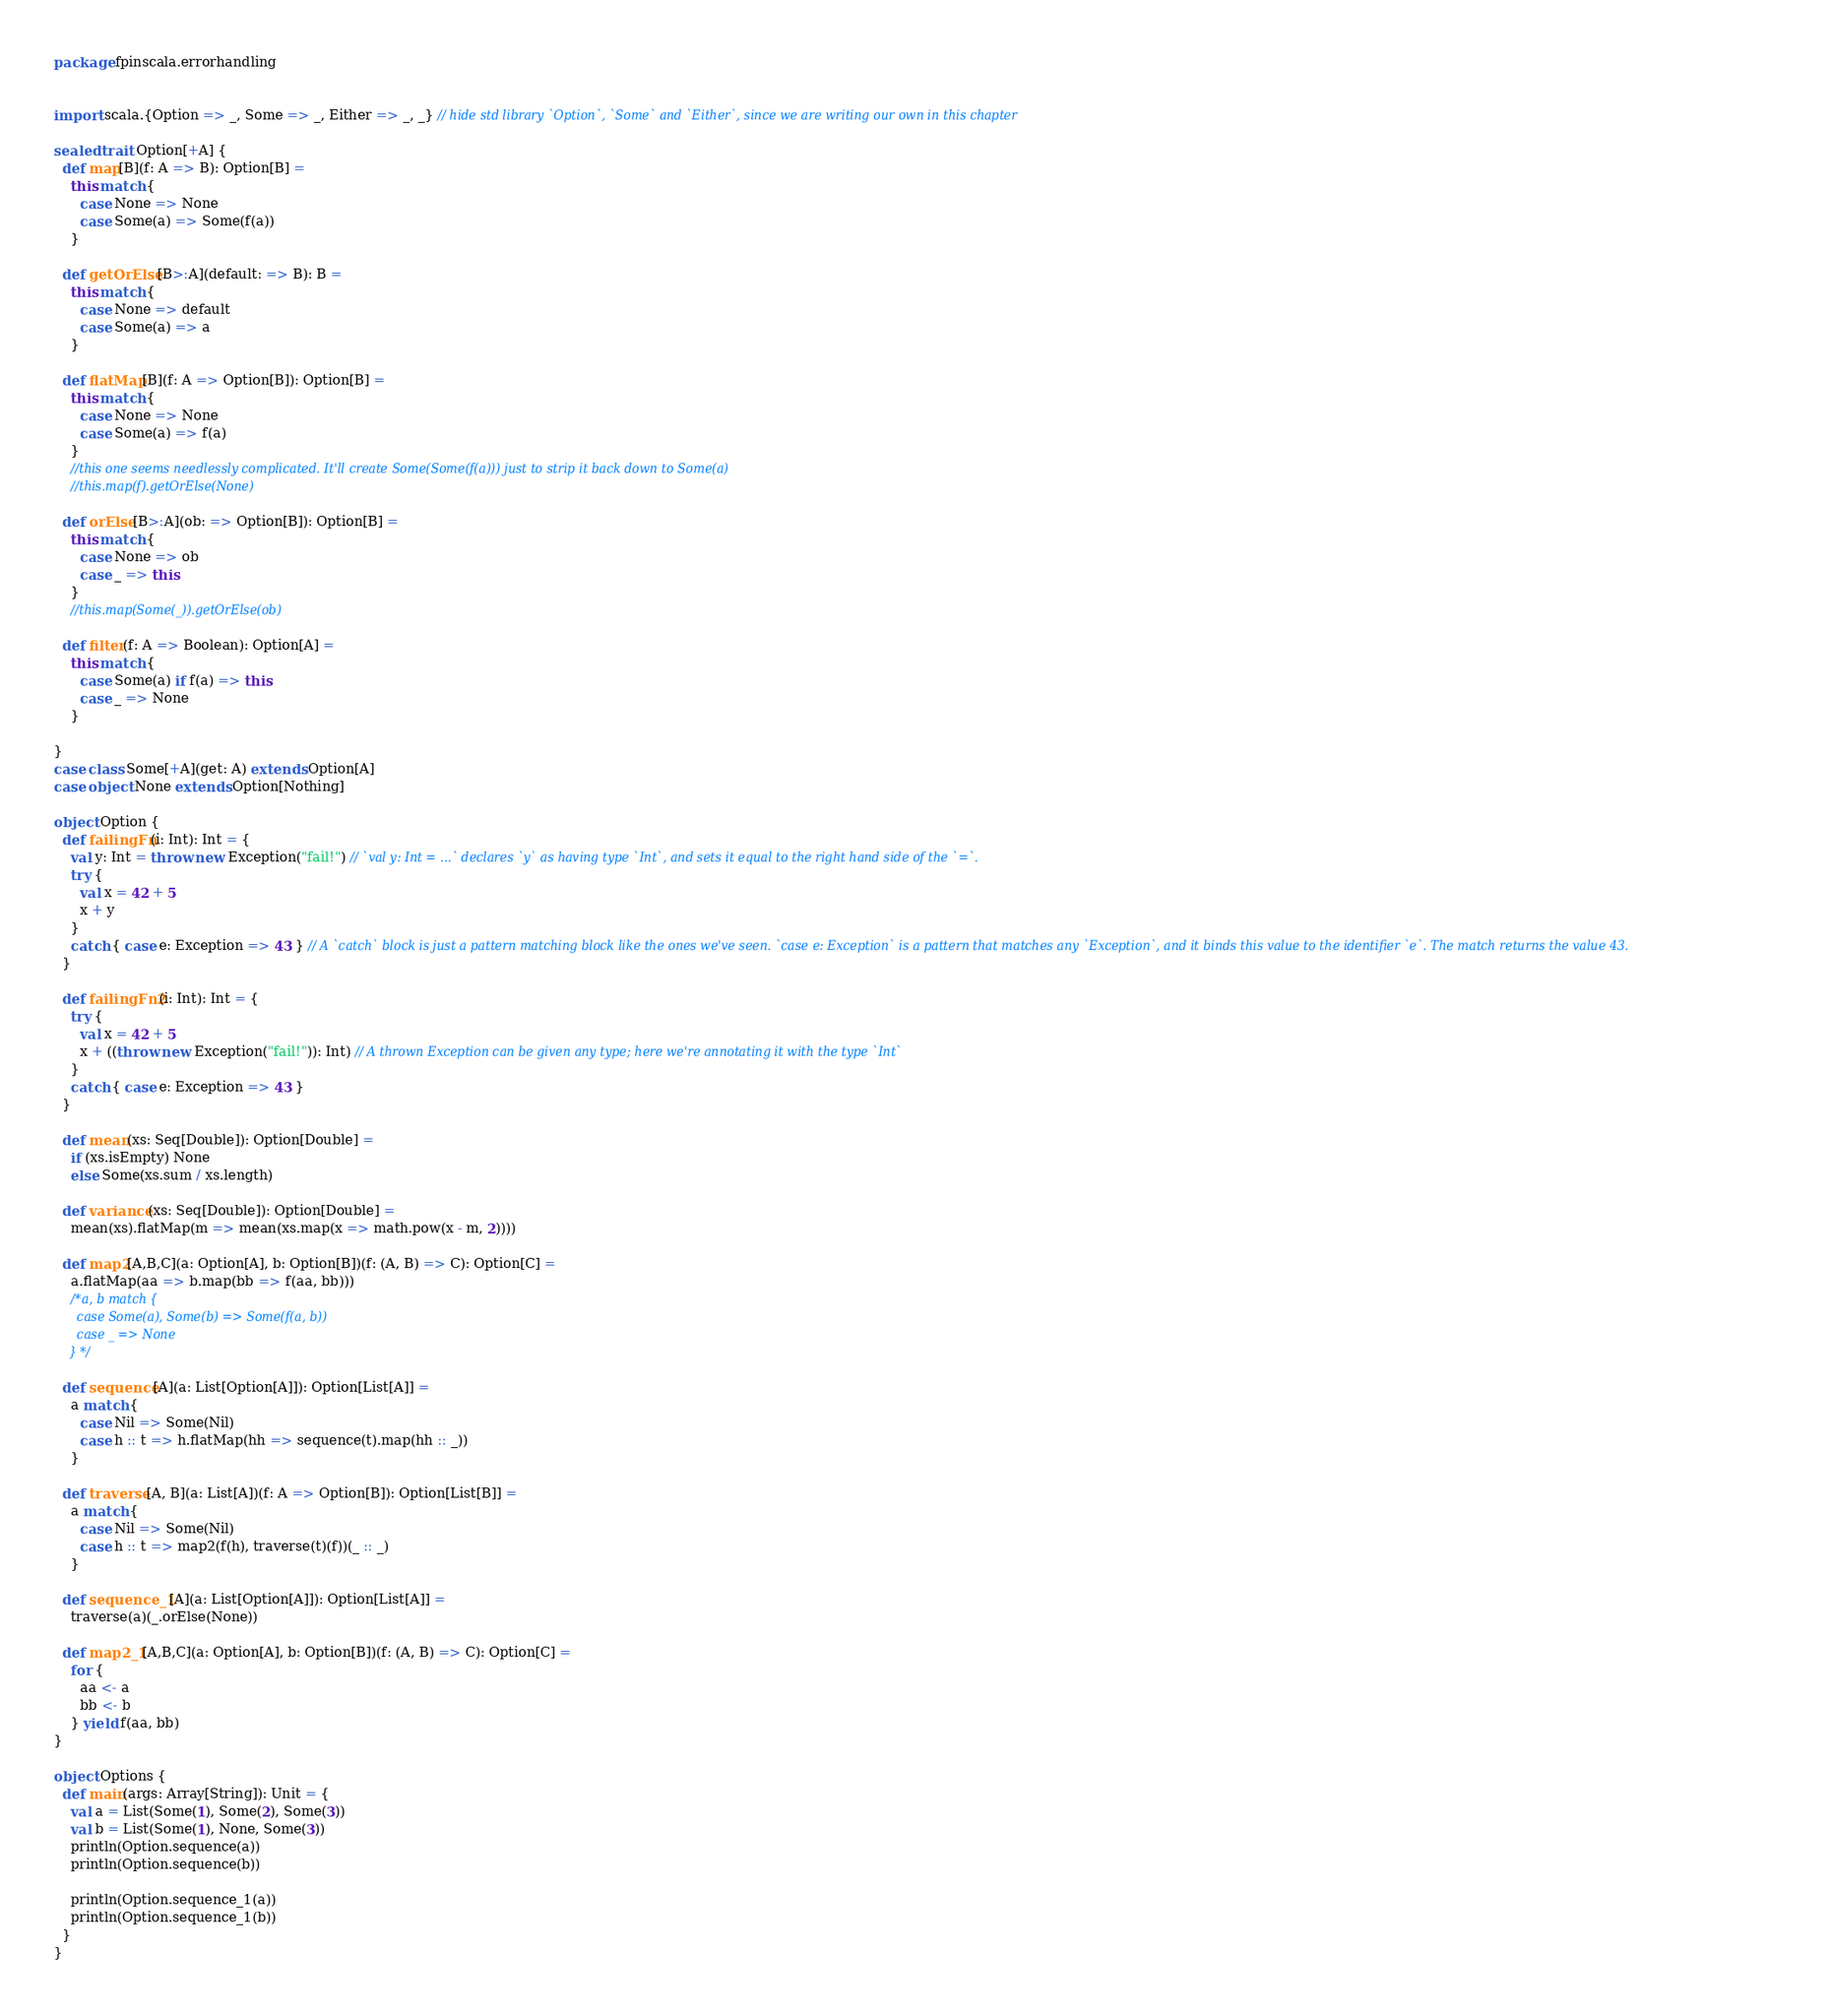Convert code to text. <code><loc_0><loc_0><loc_500><loc_500><_Scala_>package fpinscala.errorhandling


import scala.{Option => _, Some => _, Either => _, _} // hide std library `Option`, `Some` and `Either`, since we are writing our own in this chapter

sealed trait Option[+A] {
  def map[B](f: A => B): Option[B] =
    this match {
      case None => None
      case Some(a) => Some(f(a))
    }

  def getOrElse[B>:A](default: => B): B =
    this match {
      case None => default
      case Some(a) => a
    }

  def flatMap[B](f: A => Option[B]): Option[B] =
    this match {
      case None => None
      case Some(a) => f(a)
    }
    //this one seems needlessly complicated. It'll create Some(Some(f(a))) just to strip it back down to Some(a)
    //this.map(f).getOrElse(None)

  def orElse[B>:A](ob: => Option[B]): Option[B] =
    this match {
      case None => ob
      case _ => this
    }
    //this.map(Some(_)).getOrElse(ob)

  def filter(f: A => Boolean): Option[A] =
    this match {
      case Some(a) if f(a) => this
      case _ => None
    }

}
case class Some[+A](get: A) extends Option[A]
case object None extends Option[Nothing]

object Option {
  def failingFn(i: Int): Int = {
    val y: Int = throw new Exception("fail!") // `val y: Int = ...` declares `y` as having type `Int`, and sets it equal to the right hand side of the `=`.
    try {
      val x = 42 + 5
      x + y
    }
    catch { case e: Exception => 43 } // A `catch` block is just a pattern matching block like the ones we've seen. `case e: Exception` is a pattern that matches any `Exception`, and it binds this value to the identifier `e`. The match returns the value 43.
  }

  def failingFn2(i: Int): Int = {
    try {
      val x = 42 + 5
      x + ((throw new Exception("fail!")): Int) // A thrown Exception can be given any type; here we're annotating it with the type `Int`
    }
    catch { case e: Exception => 43 }
  }

  def mean(xs: Seq[Double]): Option[Double] =
    if (xs.isEmpty) None
    else Some(xs.sum / xs.length)

  def variance(xs: Seq[Double]): Option[Double] =
    mean(xs).flatMap(m => mean(xs.map(x => math.pow(x - m, 2))))

  def map2[A,B,C](a: Option[A], b: Option[B])(f: (A, B) => C): Option[C] =
    a.flatMap(aa => b.map(bb => f(aa, bb)))
    /*a, b match {
      case Some(a), Some(b) => Some(f(a, b))
      case _ => None
    }*/

  def sequence[A](a: List[Option[A]]): Option[List[A]] =
    a match {
      case Nil => Some(Nil)
      case h :: t => h.flatMap(hh => sequence(t).map(hh :: _))
    }

  def traverse[A, B](a: List[A])(f: A => Option[B]): Option[List[B]] =
    a match {
      case Nil => Some(Nil)
      case h :: t => map2(f(h), traverse(t)(f))(_ :: _)
    }

  def sequence_1[A](a: List[Option[A]]): Option[List[A]] =
    traverse(a)(_.orElse(None))

  def map2_1[A,B,C](a: Option[A], b: Option[B])(f: (A, B) => C): Option[C] =
    for {
      aa <- a
      bb <- b
    } yield f(aa, bb)
}

object Options {
  def main(args: Array[String]): Unit = {
    val a = List(Some(1), Some(2), Some(3))
    val b = List(Some(1), None, Some(3))
    println(Option.sequence(a))
    println(Option.sequence(b))

    println(Option.sequence_1(a))
    println(Option.sequence_1(b))
  }
}
</code> 